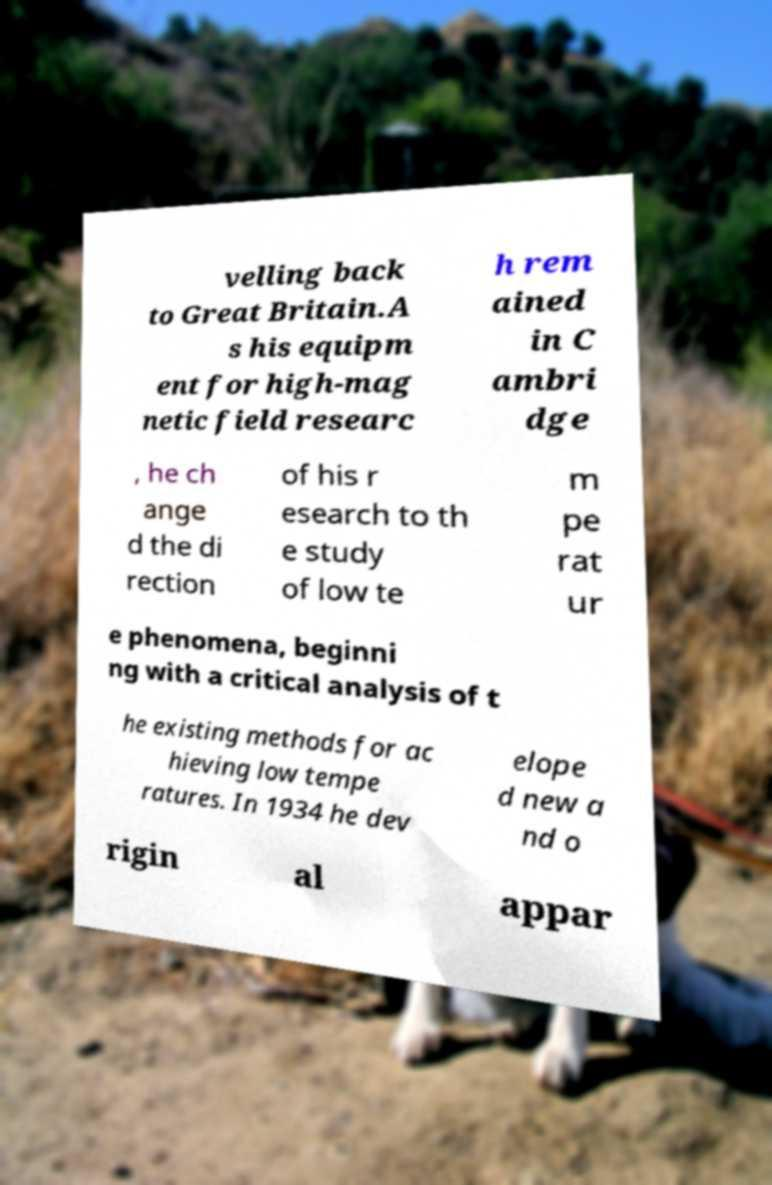Could you extract and type out the text from this image? velling back to Great Britain.A s his equipm ent for high-mag netic field researc h rem ained in C ambri dge , he ch ange d the di rection of his r esearch to th e study of low te m pe rat ur e phenomena, beginni ng with a critical analysis of t he existing methods for ac hieving low tempe ratures. In 1934 he dev elope d new a nd o rigin al appar 